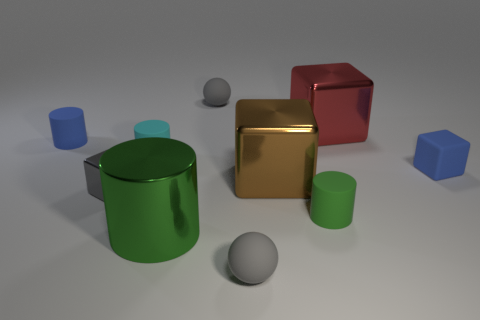Subtract all cylinders. How many objects are left? 6 Subtract 0 purple blocks. How many objects are left? 10 Subtract all rubber cylinders. Subtract all cyan matte cylinders. How many objects are left? 6 Add 3 small green cylinders. How many small green cylinders are left? 4 Add 1 small cyan rubber cylinders. How many small cyan rubber cylinders exist? 2 